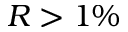<formula> <loc_0><loc_0><loc_500><loc_500>R > 1 \%</formula> 